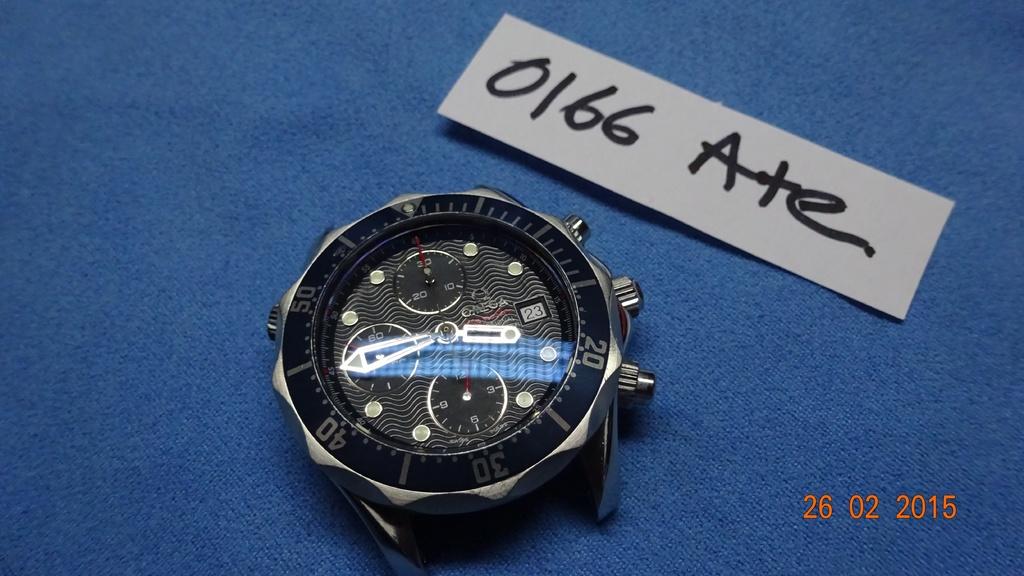What time does the clock say it is?
Ensure brevity in your answer.  3:44. Whats the date displayed?
Provide a short and direct response. February 26th 2015. 